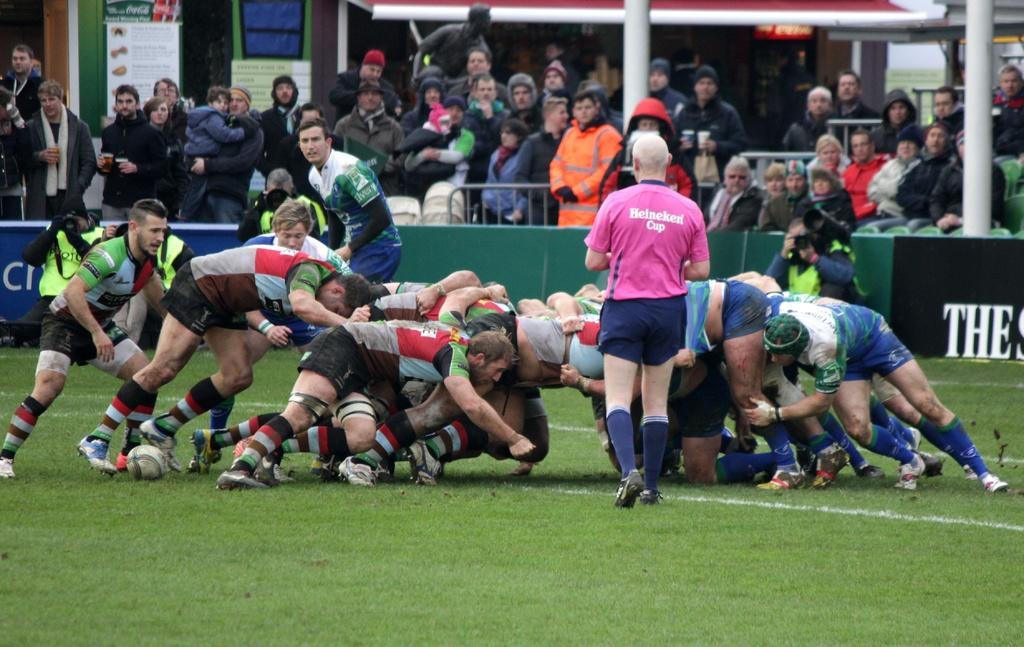How would you summarize this image in a sentence or two? In this image we can see a few people, some of them are playing American football on the ground, a person is taking pictures with a camera, also we can see some boards with some texts written on it, also we can see shops, and poles. 